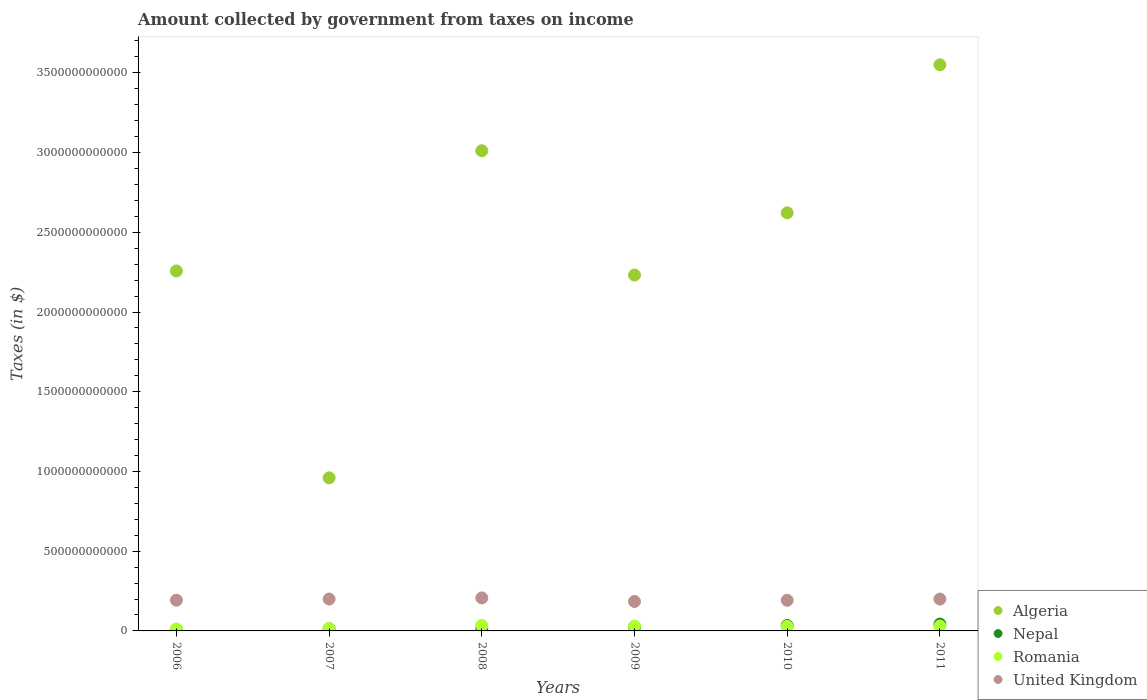How many different coloured dotlines are there?
Your response must be concise. 4. What is the amount collected by government from taxes on income in United Kingdom in 2009?
Offer a terse response. 1.85e+11. Across all years, what is the maximum amount collected by government from taxes on income in Romania?
Give a very brief answer. 3.40e+1. Across all years, what is the minimum amount collected by government from taxes on income in Romania?
Your answer should be very brief. 1.19e+1. What is the total amount collected by government from taxes on income in Algeria in the graph?
Offer a terse response. 1.46e+13. What is the difference between the amount collected by government from taxes on income in Nepal in 2008 and that in 2009?
Your answer should be compact. -7.42e+09. What is the difference between the amount collected by government from taxes on income in Algeria in 2007 and the amount collected by government from taxes on income in Romania in 2010?
Your response must be concise. 9.32e+11. What is the average amount collected by government from taxes on income in Nepal per year?
Keep it short and to the point. 2.34e+1. In the year 2008, what is the difference between the amount collected by government from taxes on income in United Kingdom and amount collected by government from taxes on income in Romania?
Your answer should be compact. 1.73e+11. What is the ratio of the amount collected by government from taxes on income in Nepal in 2006 to that in 2007?
Your answer should be very brief. 0.67. Is the amount collected by government from taxes on income in Romania in 2006 less than that in 2009?
Provide a succinct answer. Yes. Is the difference between the amount collected by government from taxes on income in United Kingdom in 2009 and 2010 greater than the difference between the amount collected by government from taxes on income in Romania in 2009 and 2010?
Your response must be concise. No. What is the difference between the highest and the second highest amount collected by government from taxes on income in United Kingdom?
Your answer should be compact. 6.88e+09. What is the difference between the highest and the lowest amount collected by government from taxes on income in Romania?
Ensure brevity in your answer.  2.21e+1. Is the sum of the amount collected by government from taxes on income in Algeria in 2007 and 2009 greater than the maximum amount collected by government from taxes on income in Nepal across all years?
Your answer should be very brief. Yes. Is the amount collected by government from taxes on income in Algeria strictly greater than the amount collected by government from taxes on income in Nepal over the years?
Ensure brevity in your answer.  Yes. How many dotlines are there?
Offer a very short reply. 4. What is the difference between two consecutive major ticks on the Y-axis?
Your answer should be compact. 5.00e+11. Where does the legend appear in the graph?
Offer a very short reply. Bottom right. What is the title of the graph?
Make the answer very short. Amount collected by government from taxes on income. Does "Namibia" appear as one of the legend labels in the graph?
Your answer should be very brief. No. What is the label or title of the X-axis?
Provide a succinct answer. Years. What is the label or title of the Y-axis?
Your answer should be compact. Taxes (in $). What is the Taxes (in $) of Algeria in 2006?
Ensure brevity in your answer.  2.26e+12. What is the Taxes (in $) of Nepal in 2006?
Your answer should be very brief. 9.16e+09. What is the Taxes (in $) of Romania in 2006?
Make the answer very short. 1.19e+1. What is the Taxes (in $) of United Kingdom in 2006?
Your answer should be very brief. 1.93e+11. What is the Taxes (in $) in Algeria in 2007?
Offer a terse response. 9.60e+11. What is the Taxes (in $) in Nepal in 2007?
Your answer should be very brief. 1.37e+1. What is the Taxes (in $) of Romania in 2007?
Your answer should be compact. 1.50e+1. What is the Taxes (in $) of United Kingdom in 2007?
Give a very brief answer. 2.00e+11. What is the Taxes (in $) in Algeria in 2008?
Your answer should be compact. 3.01e+12. What is the Taxes (in $) of Nepal in 2008?
Make the answer very short. 1.66e+1. What is the Taxes (in $) in Romania in 2008?
Provide a short and direct response. 3.40e+1. What is the Taxes (in $) in United Kingdom in 2008?
Make the answer very short. 2.07e+11. What is the Taxes (in $) of Algeria in 2009?
Your response must be concise. 2.23e+12. What is the Taxes (in $) in Nepal in 2009?
Your response must be concise. 2.41e+1. What is the Taxes (in $) of Romania in 2009?
Offer a very short reply. 3.06e+1. What is the Taxes (in $) of United Kingdom in 2009?
Provide a succinct answer. 1.85e+11. What is the Taxes (in $) in Algeria in 2010?
Make the answer very short. 2.62e+12. What is the Taxes (in $) of Nepal in 2010?
Keep it short and to the point. 3.38e+1. What is the Taxes (in $) of Romania in 2010?
Your answer should be compact. 2.82e+1. What is the Taxes (in $) in United Kingdom in 2010?
Your answer should be compact. 1.92e+11. What is the Taxes (in $) in Algeria in 2011?
Your answer should be compact. 3.55e+12. What is the Taxes (in $) in Nepal in 2011?
Offer a terse response. 4.31e+1. What is the Taxes (in $) in Romania in 2011?
Provide a succinct answer. 3.03e+1. What is the Taxes (in $) in United Kingdom in 2011?
Give a very brief answer. 2.00e+11. Across all years, what is the maximum Taxes (in $) of Algeria?
Offer a very short reply. 3.55e+12. Across all years, what is the maximum Taxes (in $) of Nepal?
Your answer should be very brief. 4.31e+1. Across all years, what is the maximum Taxes (in $) in Romania?
Provide a short and direct response. 3.40e+1. Across all years, what is the maximum Taxes (in $) of United Kingdom?
Give a very brief answer. 2.07e+11. Across all years, what is the minimum Taxes (in $) in Algeria?
Make the answer very short. 9.60e+11. Across all years, what is the minimum Taxes (in $) in Nepal?
Your answer should be very brief. 9.16e+09. Across all years, what is the minimum Taxes (in $) in Romania?
Your answer should be compact. 1.19e+1. Across all years, what is the minimum Taxes (in $) in United Kingdom?
Offer a terse response. 1.85e+11. What is the total Taxes (in $) in Algeria in the graph?
Give a very brief answer. 1.46e+13. What is the total Taxes (in $) in Nepal in the graph?
Make the answer very short. 1.41e+11. What is the total Taxes (in $) in Romania in the graph?
Your answer should be very brief. 1.50e+11. What is the total Taxes (in $) in United Kingdom in the graph?
Keep it short and to the point. 1.18e+12. What is the difference between the Taxes (in $) of Algeria in 2006 and that in 2007?
Provide a short and direct response. 1.30e+12. What is the difference between the Taxes (in $) of Nepal in 2006 and that in 2007?
Provide a short and direct response. -4.56e+09. What is the difference between the Taxes (in $) in Romania in 2006 and that in 2007?
Keep it short and to the point. -3.11e+09. What is the difference between the Taxes (in $) in United Kingdom in 2006 and that in 2007?
Provide a short and direct response. -7.44e+09. What is the difference between the Taxes (in $) of Algeria in 2006 and that in 2008?
Offer a very short reply. -7.54e+11. What is the difference between the Taxes (in $) of Nepal in 2006 and that in 2008?
Ensure brevity in your answer.  -7.46e+09. What is the difference between the Taxes (in $) in Romania in 2006 and that in 2008?
Ensure brevity in your answer.  -2.21e+1. What is the difference between the Taxes (in $) in United Kingdom in 2006 and that in 2008?
Ensure brevity in your answer.  -1.43e+1. What is the difference between the Taxes (in $) in Algeria in 2006 and that in 2009?
Your response must be concise. 2.57e+1. What is the difference between the Taxes (in $) in Nepal in 2006 and that in 2009?
Keep it short and to the point. -1.49e+1. What is the difference between the Taxes (in $) in Romania in 2006 and that in 2009?
Your answer should be very brief. -1.87e+1. What is the difference between the Taxes (in $) of United Kingdom in 2006 and that in 2009?
Make the answer very short. 7.80e+09. What is the difference between the Taxes (in $) in Algeria in 2006 and that in 2010?
Give a very brief answer. -3.65e+11. What is the difference between the Taxes (in $) in Nepal in 2006 and that in 2010?
Offer a very short reply. -2.47e+1. What is the difference between the Taxes (in $) of Romania in 2006 and that in 2010?
Offer a very short reply. -1.63e+1. What is the difference between the Taxes (in $) in United Kingdom in 2006 and that in 2010?
Ensure brevity in your answer.  4.79e+08. What is the difference between the Taxes (in $) in Algeria in 2006 and that in 2011?
Provide a short and direct response. -1.29e+12. What is the difference between the Taxes (in $) of Nepal in 2006 and that in 2011?
Offer a terse response. -3.40e+1. What is the difference between the Taxes (in $) in Romania in 2006 and that in 2011?
Give a very brief answer. -1.84e+1. What is the difference between the Taxes (in $) of United Kingdom in 2006 and that in 2011?
Give a very brief answer. -7.14e+09. What is the difference between the Taxes (in $) of Algeria in 2007 and that in 2008?
Provide a short and direct response. -2.05e+12. What is the difference between the Taxes (in $) in Nepal in 2007 and that in 2008?
Keep it short and to the point. -2.90e+09. What is the difference between the Taxes (in $) of Romania in 2007 and that in 2008?
Offer a very short reply. -1.90e+1. What is the difference between the Taxes (in $) in United Kingdom in 2007 and that in 2008?
Offer a very short reply. -6.88e+09. What is the difference between the Taxes (in $) in Algeria in 2007 and that in 2009?
Offer a very short reply. -1.27e+12. What is the difference between the Taxes (in $) in Nepal in 2007 and that in 2009?
Provide a succinct answer. -1.03e+1. What is the difference between the Taxes (in $) of Romania in 2007 and that in 2009?
Make the answer very short. -1.56e+1. What is the difference between the Taxes (in $) in United Kingdom in 2007 and that in 2009?
Offer a terse response. 1.52e+1. What is the difference between the Taxes (in $) of Algeria in 2007 and that in 2010?
Your answer should be compact. -1.66e+12. What is the difference between the Taxes (in $) in Nepal in 2007 and that in 2010?
Provide a succinct answer. -2.01e+1. What is the difference between the Taxes (in $) in Romania in 2007 and that in 2010?
Give a very brief answer. -1.32e+1. What is the difference between the Taxes (in $) of United Kingdom in 2007 and that in 2010?
Your answer should be very brief. 7.92e+09. What is the difference between the Taxes (in $) of Algeria in 2007 and that in 2011?
Offer a very short reply. -2.59e+12. What is the difference between the Taxes (in $) of Nepal in 2007 and that in 2011?
Offer a terse response. -2.94e+1. What is the difference between the Taxes (in $) in Romania in 2007 and that in 2011?
Provide a succinct answer. -1.53e+1. What is the difference between the Taxes (in $) in United Kingdom in 2007 and that in 2011?
Give a very brief answer. 3.00e+08. What is the difference between the Taxes (in $) in Algeria in 2008 and that in 2009?
Make the answer very short. 7.80e+11. What is the difference between the Taxes (in $) in Nepal in 2008 and that in 2009?
Provide a short and direct response. -7.42e+09. What is the difference between the Taxes (in $) of Romania in 2008 and that in 2009?
Keep it short and to the point. 3.39e+09. What is the difference between the Taxes (in $) of United Kingdom in 2008 and that in 2009?
Give a very brief answer. 2.21e+1. What is the difference between the Taxes (in $) of Algeria in 2008 and that in 2010?
Your answer should be compact. 3.89e+11. What is the difference between the Taxes (in $) of Nepal in 2008 and that in 2010?
Offer a terse response. -1.72e+1. What is the difference between the Taxes (in $) of Romania in 2008 and that in 2010?
Provide a succinct answer. 5.76e+09. What is the difference between the Taxes (in $) in United Kingdom in 2008 and that in 2010?
Make the answer very short. 1.48e+1. What is the difference between the Taxes (in $) of Algeria in 2008 and that in 2011?
Ensure brevity in your answer.  -5.39e+11. What is the difference between the Taxes (in $) in Nepal in 2008 and that in 2011?
Your answer should be very brief. -2.65e+1. What is the difference between the Taxes (in $) of Romania in 2008 and that in 2011?
Provide a succinct answer. 3.68e+09. What is the difference between the Taxes (in $) of United Kingdom in 2008 and that in 2011?
Your answer should be very brief. 7.18e+09. What is the difference between the Taxes (in $) of Algeria in 2009 and that in 2010?
Keep it short and to the point. -3.90e+11. What is the difference between the Taxes (in $) of Nepal in 2009 and that in 2010?
Ensure brevity in your answer.  -9.77e+09. What is the difference between the Taxes (in $) in Romania in 2009 and that in 2010?
Your response must be concise. 2.37e+09. What is the difference between the Taxes (in $) of United Kingdom in 2009 and that in 2010?
Offer a terse response. -7.32e+09. What is the difference between the Taxes (in $) in Algeria in 2009 and that in 2011?
Offer a very short reply. -1.32e+12. What is the difference between the Taxes (in $) in Nepal in 2009 and that in 2011?
Ensure brevity in your answer.  -1.91e+1. What is the difference between the Taxes (in $) in Romania in 2009 and that in 2011?
Keep it short and to the point. 2.83e+08. What is the difference between the Taxes (in $) of United Kingdom in 2009 and that in 2011?
Keep it short and to the point. -1.49e+1. What is the difference between the Taxes (in $) in Algeria in 2010 and that in 2011?
Make the answer very short. -9.28e+11. What is the difference between the Taxes (in $) of Nepal in 2010 and that in 2011?
Keep it short and to the point. -9.30e+09. What is the difference between the Taxes (in $) in Romania in 2010 and that in 2011?
Provide a short and direct response. -2.09e+09. What is the difference between the Taxes (in $) of United Kingdom in 2010 and that in 2011?
Make the answer very short. -7.62e+09. What is the difference between the Taxes (in $) in Algeria in 2006 and the Taxes (in $) in Nepal in 2007?
Offer a very short reply. 2.24e+12. What is the difference between the Taxes (in $) in Algeria in 2006 and the Taxes (in $) in Romania in 2007?
Offer a very short reply. 2.24e+12. What is the difference between the Taxes (in $) of Algeria in 2006 and the Taxes (in $) of United Kingdom in 2007?
Offer a terse response. 2.06e+12. What is the difference between the Taxes (in $) of Nepal in 2006 and the Taxes (in $) of Romania in 2007?
Give a very brief answer. -5.86e+09. What is the difference between the Taxes (in $) of Nepal in 2006 and the Taxes (in $) of United Kingdom in 2007?
Offer a very short reply. -1.91e+11. What is the difference between the Taxes (in $) in Romania in 2006 and the Taxes (in $) in United Kingdom in 2007?
Your answer should be very brief. -1.88e+11. What is the difference between the Taxes (in $) of Algeria in 2006 and the Taxes (in $) of Nepal in 2008?
Make the answer very short. 2.24e+12. What is the difference between the Taxes (in $) in Algeria in 2006 and the Taxes (in $) in Romania in 2008?
Your answer should be very brief. 2.22e+12. What is the difference between the Taxes (in $) in Algeria in 2006 and the Taxes (in $) in United Kingdom in 2008?
Provide a short and direct response. 2.05e+12. What is the difference between the Taxes (in $) of Nepal in 2006 and the Taxes (in $) of Romania in 2008?
Offer a very short reply. -2.48e+1. What is the difference between the Taxes (in $) of Nepal in 2006 and the Taxes (in $) of United Kingdom in 2008?
Ensure brevity in your answer.  -1.98e+11. What is the difference between the Taxes (in $) in Romania in 2006 and the Taxes (in $) in United Kingdom in 2008?
Provide a succinct answer. -1.95e+11. What is the difference between the Taxes (in $) in Algeria in 2006 and the Taxes (in $) in Nepal in 2009?
Give a very brief answer. 2.23e+12. What is the difference between the Taxes (in $) of Algeria in 2006 and the Taxes (in $) of Romania in 2009?
Your answer should be compact. 2.23e+12. What is the difference between the Taxes (in $) of Algeria in 2006 and the Taxes (in $) of United Kingdom in 2009?
Your answer should be very brief. 2.07e+12. What is the difference between the Taxes (in $) in Nepal in 2006 and the Taxes (in $) in Romania in 2009?
Your answer should be very brief. -2.14e+1. What is the difference between the Taxes (in $) of Nepal in 2006 and the Taxes (in $) of United Kingdom in 2009?
Give a very brief answer. -1.76e+11. What is the difference between the Taxes (in $) in Romania in 2006 and the Taxes (in $) in United Kingdom in 2009?
Give a very brief answer. -1.73e+11. What is the difference between the Taxes (in $) in Algeria in 2006 and the Taxes (in $) in Nepal in 2010?
Your response must be concise. 2.22e+12. What is the difference between the Taxes (in $) in Algeria in 2006 and the Taxes (in $) in Romania in 2010?
Your answer should be very brief. 2.23e+12. What is the difference between the Taxes (in $) in Algeria in 2006 and the Taxes (in $) in United Kingdom in 2010?
Provide a short and direct response. 2.07e+12. What is the difference between the Taxes (in $) of Nepal in 2006 and the Taxes (in $) of Romania in 2010?
Your answer should be compact. -1.91e+1. What is the difference between the Taxes (in $) in Nepal in 2006 and the Taxes (in $) in United Kingdom in 2010?
Provide a short and direct response. -1.83e+11. What is the difference between the Taxes (in $) in Romania in 2006 and the Taxes (in $) in United Kingdom in 2010?
Your response must be concise. -1.80e+11. What is the difference between the Taxes (in $) of Algeria in 2006 and the Taxes (in $) of Nepal in 2011?
Give a very brief answer. 2.21e+12. What is the difference between the Taxes (in $) in Algeria in 2006 and the Taxes (in $) in Romania in 2011?
Keep it short and to the point. 2.23e+12. What is the difference between the Taxes (in $) in Algeria in 2006 and the Taxes (in $) in United Kingdom in 2011?
Your answer should be very brief. 2.06e+12. What is the difference between the Taxes (in $) in Nepal in 2006 and the Taxes (in $) in Romania in 2011?
Keep it short and to the point. -2.12e+1. What is the difference between the Taxes (in $) in Nepal in 2006 and the Taxes (in $) in United Kingdom in 2011?
Provide a short and direct response. -1.91e+11. What is the difference between the Taxes (in $) of Romania in 2006 and the Taxes (in $) of United Kingdom in 2011?
Give a very brief answer. -1.88e+11. What is the difference between the Taxes (in $) in Algeria in 2007 and the Taxes (in $) in Nepal in 2008?
Offer a very short reply. 9.43e+11. What is the difference between the Taxes (in $) in Algeria in 2007 and the Taxes (in $) in Romania in 2008?
Ensure brevity in your answer.  9.26e+11. What is the difference between the Taxes (in $) of Algeria in 2007 and the Taxes (in $) of United Kingdom in 2008?
Offer a terse response. 7.53e+11. What is the difference between the Taxes (in $) of Nepal in 2007 and the Taxes (in $) of Romania in 2008?
Make the answer very short. -2.03e+1. What is the difference between the Taxes (in $) in Nepal in 2007 and the Taxes (in $) in United Kingdom in 2008?
Give a very brief answer. -1.93e+11. What is the difference between the Taxes (in $) of Romania in 2007 and the Taxes (in $) of United Kingdom in 2008?
Make the answer very short. -1.92e+11. What is the difference between the Taxes (in $) of Algeria in 2007 and the Taxes (in $) of Nepal in 2009?
Ensure brevity in your answer.  9.36e+11. What is the difference between the Taxes (in $) in Algeria in 2007 and the Taxes (in $) in Romania in 2009?
Your answer should be very brief. 9.29e+11. What is the difference between the Taxes (in $) of Algeria in 2007 and the Taxes (in $) of United Kingdom in 2009?
Your response must be concise. 7.75e+11. What is the difference between the Taxes (in $) in Nepal in 2007 and the Taxes (in $) in Romania in 2009?
Offer a very short reply. -1.69e+1. What is the difference between the Taxes (in $) in Nepal in 2007 and the Taxes (in $) in United Kingdom in 2009?
Provide a short and direct response. -1.71e+11. What is the difference between the Taxes (in $) of Romania in 2007 and the Taxes (in $) of United Kingdom in 2009?
Make the answer very short. -1.70e+11. What is the difference between the Taxes (in $) of Algeria in 2007 and the Taxes (in $) of Nepal in 2010?
Keep it short and to the point. 9.26e+11. What is the difference between the Taxes (in $) of Algeria in 2007 and the Taxes (in $) of Romania in 2010?
Your answer should be very brief. 9.32e+11. What is the difference between the Taxes (in $) of Algeria in 2007 and the Taxes (in $) of United Kingdom in 2010?
Offer a very short reply. 7.68e+11. What is the difference between the Taxes (in $) in Nepal in 2007 and the Taxes (in $) in Romania in 2010?
Offer a very short reply. -1.45e+1. What is the difference between the Taxes (in $) in Nepal in 2007 and the Taxes (in $) in United Kingdom in 2010?
Offer a terse response. -1.78e+11. What is the difference between the Taxes (in $) of Romania in 2007 and the Taxes (in $) of United Kingdom in 2010?
Your answer should be very brief. -1.77e+11. What is the difference between the Taxes (in $) of Algeria in 2007 and the Taxes (in $) of Nepal in 2011?
Ensure brevity in your answer.  9.17e+11. What is the difference between the Taxes (in $) of Algeria in 2007 and the Taxes (in $) of Romania in 2011?
Provide a succinct answer. 9.30e+11. What is the difference between the Taxes (in $) of Algeria in 2007 and the Taxes (in $) of United Kingdom in 2011?
Your answer should be very brief. 7.60e+11. What is the difference between the Taxes (in $) in Nepal in 2007 and the Taxes (in $) in Romania in 2011?
Offer a terse response. -1.66e+1. What is the difference between the Taxes (in $) in Nepal in 2007 and the Taxes (in $) in United Kingdom in 2011?
Offer a very short reply. -1.86e+11. What is the difference between the Taxes (in $) in Romania in 2007 and the Taxes (in $) in United Kingdom in 2011?
Your response must be concise. -1.85e+11. What is the difference between the Taxes (in $) in Algeria in 2008 and the Taxes (in $) in Nepal in 2009?
Ensure brevity in your answer.  2.99e+12. What is the difference between the Taxes (in $) of Algeria in 2008 and the Taxes (in $) of Romania in 2009?
Provide a short and direct response. 2.98e+12. What is the difference between the Taxes (in $) of Algeria in 2008 and the Taxes (in $) of United Kingdom in 2009?
Provide a short and direct response. 2.83e+12. What is the difference between the Taxes (in $) of Nepal in 2008 and the Taxes (in $) of Romania in 2009?
Make the answer very short. -1.40e+1. What is the difference between the Taxes (in $) of Nepal in 2008 and the Taxes (in $) of United Kingdom in 2009?
Give a very brief answer. -1.68e+11. What is the difference between the Taxes (in $) in Romania in 2008 and the Taxes (in $) in United Kingdom in 2009?
Provide a short and direct response. -1.51e+11. What is the difference between the Taxes (in $) of Algeria in 2008 and the Taxes (in $) of Nepal in 2010?
Provide a short and direct response. 2.98e+12. What is the difference between the Taxes (in $) in Algeria in 2008 and the Taxes (in $) in Romania in 2010?
Make the answer very short. 2.98e+12. What is the difference between the Taxes (in $) of Algeria in 2008 and the Taxes (in $) of United Kingdom in 2010?
Give a very brief answer. 2.82e+12. What is the difference between the Taxes (in $) in Nepal in 2008 and the Taxes (in $) in Romania in 2010?
Your response must be concise. -1.16e+1. What is the difference between the Taxes (in $) in Nepal in 2008 and the Taxes (in $) in United Kingdom in 2010?
Offer a very short reply. -1.75e+11. What is the difference between the Taxes (in $) of Romania in 2008 and the Taxes (in $) of United Kingdom in 2010?
Provide a short and direct response. -1.58e+11. What is the difference between the Taxes (in $) of Algeria in 2008 and the Taxes (in $) of Nepal in 2011?
Give a very brief answer. 2.97e+12. What is the difference between the Taxes (in $) in Algeria in 2008 and the Taxes (in $) in Romania in 2011?
Provide a short and direct response. 2.98e+12. What is the difference between the Taxes (in $) in Algeria in 2008 and the Taxes (in $) in United Kingdom in 2011?
Offer a very short reply. 2.81e+12. What is the difference between the Taxes (in $) in Nepal in 2008 and the Taxes (in $) in Romania in 2011?
Your response must be concise. -1.37e+1. What is the difference between the Taxes (in $) of Nepal in 2008 and the Taxes (in $) of United Kingdom in 2011?
Provide a succinct answer. -1.83e+11. What is the difference between the Taxes (in $) of Romania in 2008 and the Taxes (in $) of United Kingdom in 2011?
Make the answer very short. -1.66e+11. What is the difference between the Taxes (in $) in Algeria in 2009 and the Taxes (in $) in Nepal in 2010?
Keep it short and to the point. 2.20e+12. What is the difference between the Taxes (in $) in Algeria in 2009 and the Taxes (in $) in Romania in 2010?
Offer a terse response. 2.20e+12. What is the difference between the Taxes (in $) of Algeria in 2009 and the Taxes (in $) of United Kingdom in 2010?
Make the answer very short. 2.04e+12. What is the difference between the Taxes (in $) in Nepal in 2009 and the Taxes (in $) in Romania in 2010?
Give a very brief answer. -4.19e+09. What is the difference between the Taxes (in $) in Nepal in 2009 and the Taxes (in $) in United Kingdom in 2010?
Your answer should be compact. -1.68e+11. What is the difference between the Taxes (in $) of Romania in 2009 and the Taxes (in $) of United Kingdom in 2010?
Give a very brief answer. -1.62e+11. What is the difference between the Taxes (in $) of Algeria in 2009 and the Taxes (in $) of Nepal in 2011?
Your answer should be very brief. 2.19e+12. What is the difference between the Taxes (in $) of Algeria in 2009 and the Taxes (in $) of Romania in 2011?
Provide a short and direct response. 2.20e+12. What is the difference between the Taxes (in $) of Algeria in 2009 and the Taxes (in $) of United Kingdom in 2011?
Offer a terse response. 2.03e+12. What is the difference between the Taxes (in $) of Nepal in 2009 and the Taxes (in $) of Romania in 2011?
Offer a terse response. -6.28e+09. What is the difference between the Taxes (in $) in Nepal in 2009 and the Taxes (in $) in United Kingdom in 2011?
Make the answer very short. -1.76e+11. What is the difference between the Taxes (in $) of Romania in 2009 and the Taxes (in $) of United Kingdom in 2011?
Your answer should be very brief. -1.69e+11. What is the difference between the Taxes (in $) of Algeria in 2010 and the Taxes (in $) of Nepal in 2011?
Provide a short and direct response. 2.58e+12. What is the difference between the Taxes (in $) of Algeria in 2010 and the Taxes (in $) of Romania in 2011?
Provide a short and direct response. 2.59e+12. What is the difference between the Taxes (in $) in Algeria in 2010 and the Taxes (in $) in United Kingdom in 2011?
Give a very brief answer. 2.42e+12. What is the difference between the Taxes (in $) of Nepal in 2010 and the Taxes (in $) of Romania in 2011?
Your answer should be compact. 3.49e+09. What is the difference between the Taxes (in $) in Nepal in 2010 and the Taxes (in $) in United Kingdom in 2011?
Your answer should be compact. -1.66e+11. What is the difference between the Taxes (in $) of Romania in 2010 and the Taxes (in $) of United Kingdom in 2011?
Offer a very short reply. -1.71e+11. What is the average Taxes (in $) in Algeria per year?
Your response must be concise. 2.44e+12. What is the average Taxes (in $) in Nepal per year?
Provide a succinct answer. 2.34e+1. What is the average Taxes (in $) in Romania per year?
Your response must be concise. 2.50e+1. What is the average Taxes (in $) in United Kingdom per year?
Your response must be concise. 1.96e+11. In the year 2006, what is the difference between the Taxes (in $) in Algeria and Taxes (in $) in Nepal?
Provide a short and direct response. 2.25e+12. In the year 2006, what is the difference between the Taxes (in $) of Algeria and Taxes (in $) of Romania?
Offer a very short reply. 2.25e+12. In the year 2006, what is the difference between the Taxes (in $) in Algeria and Taxes (in $) in United Kingdom?
Offer a very short reply. 2.06e+12. In the year 2006, what is the difference between the Taxes (in $) in Nepal and Taxes (in $) in Romania?
Ensure brevity in your answer.  -2.75e+09. In the year 2006, what is the difference between the Taxes (in $) in Nepal and Taxes (in $) in United Kingdom?
Offer a terse response. -1.83e+11. In the year 2006, what is the difference between the Taxes (in $) of Romania and Taxes (in $) of United Kingdom?
Make the answer very short. -1.81e+11. In the year 2007, what is the difference between the Taxes (in $) of Algeria and Taxes (in $) of Nepal?
Keep it short and to the point. 9.46e+11. In the year 2007, what is the difference between the Taxes (in $) of Algeria and Taxes (in $) of Romania?
Give a very brief answer. 9.45e+11. In the year 2007, what is the difference between the Taxes (in $) in Algeria and Taxes (in $) in United Kingdom?
Make the answer very short. 7.60e+11. In the year 2007, what is the difference between the Taxes (in $) in Nepal and Taxes (in $) in Romania?
Provide a short and direct response. -1.30e+09. In the year 2007, what is the difference between the Taxes (in $) of Nepal and Taxes (in $) of United Kingdom?
Provide a succinct answer. -1.86e+11. In the year 2007, what is the difference between the Taxes (in $) in Romania and Taxes (in $) in United Kingdom?
Give a very brief answer. -1.85e+11. In the year 2008, what is the difference between the Taxes (in $) of Algeria and Taxes (in $) of Nepal?
Give a very brief answer. 2.99e+12. In the year 2008, what is the difference between the Taxes (in $) of Algeria and Taxes (in $) of Romania?
Give a very brief answer. 2.98e+12. In the year 2008, what is the difference between the Taxes (in $) of Algeria and Taxes (in $) of United Kingdom?
Provide a short and direct response. 2.80e+12. In the year 2008, what is the difference between the Taxes (in $) of Nepal and Taxes (in $) of Romania?
Your response must be concise. -1.74e+1. In the year 2008, what is the difference between the Taxes (in $) in Nepal and Taxes (in $) in United Kingdom?
Provide a succinct answer. -1.90e+11. In the year 2008, what is the difference between the Taxes (in $) of Romania and Taxes (in $) of United Kingdom?
Provide a short and direct response. -1.73e+11. In the year 2009, what is the difference between the Taxes (in $) of Algeria and Taxes (in $) of Nepal?
Make the answer very short. 2.21e+12. In the year 2009, what is the difference between the Taxes (in $) in Algeria and Taxes (in $) in Romania?
Make the answer very short. 2.20e+12. In the year 2009, what is the difference between the Taxes (in $) in Algeria and Taxes (in $) in United Kingdom?
Offer a terse response. 2.05e+12. In the year 2009, what is the difference between the Taxes (in $) of Nepal and Taxes (in $) of Romania?
Offer a very short reply. -6.56e+09. In the year 2009, what is the difference between the Taxes (in $) in Nepal and Taxes (in $) in United Kingdom?
Give a very brief answer. -1.61e+11. In the year 2009, what is the difference between the Taxes (in $) of Romania and Taxes (in $) of United Kingdom?
Provide a short and direct response. -1.54e+11. In the year 2010, what is the difference between the Taxes (in $) in Algeria and Taxes (in $) in Nepal?
Your response must be concise. 2.59e+12. In the year 2010, what is the difference between the Taxes (in $) of Algeria and Taxes (in $) of Romania?
Provide a short and direct response. 2.59e+12. In the year 2010, what is the difference between the Taxes (in $) of Algeria and Taxes (in $) of United Kingdom?
Your answer should be compact. 2.43e+12. In the year 2010, what is the difference between the Taxes (in $) of Nepal and Taxes (in $) of Romania?
Offer a terse response. 5.58e+09. In the year 2010, what is the difference between the Taxes (in $) of Nepal and Taxes (in $) of United Kingdom?
Ensure brevity in your answer.  -1.58e+11. In the year 2010, what is the difference between the Taxes (in $) in Romania and Taxes (in $) in United Kingdom?
Offer a terse response. -1.64e+11. In the year 2011, what is the difference between the Taxes (in $) in Algeria and Taxes (in $) in Nepal?
Your answer should be compact. 3.51e+12. In the year 2011, what is the difference between the Taxes (in $) in Algeria and Taxes (in $) in Romania?
Keep it short and to the point. 3.52e+12. In the year 2011, what is the difference between the Taxes (in $) in Algeria and Taxes (in $) in United Kingdom?
Offer a very short reply. 3.35e+12. In the year 2011, what is the difference between the Taxes (in $) of Nepal and Taxes (in $) of Romania?
Make the answer very short. 1.28e+1. In the year 2011, what is the difference between the Taxes (in $) of Nepal and Taxes (in $) of United Kingdom?
Provide a short and direct response. -1.57e+11. In the year 2011, what is the difference between the Taxes (in $) in Romania and Taxes (in $) in United Kingdom?
Make the answer very short. -1.69e+11. What is the ratio of the Taxes (in $) in Algeria in 2006 to that in 2007?
Offer a very short reply. 2.35. What is the ratio of the Taxes (in $) in Nepal in 2006 to that in 2007?
Make the answer very short. 0.67. What is the ratio of the Taxes (in $) of Romania in 2006 to that in 2007?
Your response must be concise. 0.79. What is the ratio of the Taxes (in $) in United Kingdom in 2006 to that in 2007?
Make the answer very short. 0.96. What is the ratio of the Taxes (in $) in Algeria in 2006 to that in 2008?
Provide a succinct answer. 0.75. What is the ratio of the Taxes (in $) in Nepal in 2006 to that in 2008?
Your answer should be compact. 0.55. What is the ratio of the Taxes (in $) of Romania in 2006 to that in 2008?
Your answer should be very brief. 0.35. What is the ratio of the Taxes (in $) of United Kingdom in 2006 to that in 2008?
Give a very brief answer. 0.93. What is the ratio of the Taxes (in $) in Algeria in 2006 to that in 2009?
Offer a very short reply. 1.01. What is the ratio of the Taxes (in $) in Nepal in 2006 to that in 2009?
Provide a short and direct response. 0.38. What is the ratio of the Taxes (in $) in Romania in 2006 to that in 2009?
Keep it short and to the point. 0.39. What is the ratio of the Taxes (in $) in United Kingdom in 2006 to that in 2009?
Make the answer very short. 1.04. What is the ratio of the Taxes (in $) of Algeria in 2006 to that in 2010?
Your answer should be very brief. 0.86. What is the ratio of the Taxes (in $) in Nepal in 2006 to that in 2010?
Offer a terse response. 0.27. What is the ratio of the Taxes (in $) of Romania in 2006 to that in 2010?
Your answer should be compact. 0.42. What is the ratio of the Taxes (in $) in Algeria in 2006 to that in 2011?
Offer a terse response. 0.64. What is the ratio of the Taxes (in $) of Nepal in 2006 to that in 2011?
Offer a terse response. 0.21. What is the ratio of the Taxes (in $) in Romania in 2006 to that in 2011?
Ensure brevity in your answer.  0.39. What is the ratio of the Taxes (in $) of United Kingdom in 2006 to that in 2011?
Offer a very short reply. 0.96. What is the ratio of the Taxes (in $) of Algeria in 2007 to that in 2008?
Provide a succinct answer. 0.32. What is the ratio of the Taxes (in $) in Nepal in 2007 to that in 2008?
Give a very brief answer. 0.83. What is the ratio of the Taxes (in $) in Romania in 2007 to that in 2008?
Ensure brevity in your answer.  0.44. What is the ratio of the Taxes (in $) of United Kingdom in 2007 to that in 2008?
Provide a short and direct response. 0.97. What is the ratio of the Taxes (in $) of Algeria in 2007 to that in 2009?
Provide a succinct answer. 0.43. What is the ratio of the Taxes (in $) in Nepal in 2007 to that in 2009?
Your answer should be very brief. 0.57. What is the ratio of the Taxes (in $) in Romania in 2007 to that in 2009?
Offer a very short reply. 0.49. What is the ratio of the Taxes (in $) in United Kingdom in 2007 to that in 2009?
Your response must be concise. 1.08. What is the ratio of the Taxes (in $) of Algeria in 2007 to that in 2010?
Ensure brevity in your answer.  0.37. What is the ratio of the Taxes (in $) of Nepal in 2007 to that in 2010?
Give a very brief answer. 0.41. What is the ratio of the Taxes (in $) in Romania in 2007 to that in 2010?
Your response must be concise. 0.53. What is the ratio of the Taxes (in $) in United Kingdom in 2007 to that in 2010?
Offer a terse response. 1.04. What is the ratio of the Taxes (in $) in Algeria in 2007 to that in 2011?
Make the answer very short. 0.27. What is the ratio of the Taxes (in $) of Nepal in 2007 to that in 2011?
Offer a terse response. 0.32. What is the ratio of the Taxes (in $) in Romania in 2007 to that in 2011?
Your answer should be very brief. 0.5. What is the ratio of the Taxes (in $) of United Kingdom in 2007 to that in 2011?
Provide a succinct answer. 1. What is the ratio of the Taxes (in $) of Algeria in 2008 to that in 2009?
Make the answer very short. 1.35. What is the ratio of the Taxes (in $) of Nepal in 2008 to that in 2009?
Your response must be concise. 0.69. What is the ratio of the Taxes (in $) in Romania in 2008 to that in 2009?
Ensure brevity in your answer.  1.11. What is the ratio of the Taxes (in $) in United Kingdom in 2008 to that in 2009?
Offer a very short reply. 1.12. What is the ratio of the Taxes (in $) in Algeria in 2008 to that in 2010?
Ensure brevity in your answer.  1.15. What is the ratio of the Taxes (in $) in Nepal in 2008 to that in 2010?
Ensure brevity in your answer.  0.49. What is the ratio of the Taxes (in $) of Romania in 2008 to that in 2010?
Ensure brevity in your answer.  1.2. What is the ratio of the Taxes (in $) in United Kingdom in 2008 to that in 2010?
Offer a terse response. 1.08. What is the ratio of the Taxes (in $) of Algeria in 2008 to that in 2011?
Your answer should be very brief. 0.85. What is the ratio of the Taxes (in $) of Nepal in 2008 to that in 2011?
Your answer should be compact. 0.39. What is the ratio of the Taxes (in $) of Romania in 2008 to that in 2011?
Give a very brief answer. 1.12. What is the ratio of the Taxes (in $) of United Kingdom in 2008 to that in 2011?
Keep it short and to the point. 1.04. What is the ratio of the Taxes (in $) in Algeria in 2009 to that in 2010?
Make the answer very short. 0.85. What is the ratio of the Taxes (in $) of Nepal in 2009 to that in 2010?
Give a very brief answer. 0.71. What is the ratio of the Taxes (in $) in Romania in 2009 to that in 2010?
Provide a succinct answer. 1.08. What is the ratio of the Taxes (in $) of United Kingdom in 2009 to that in 2010?
Your answer should be very brief. 0.96. What is the ratio of the Taxes (in $) of Algeria in 2009 to that in 2011?
Your answer should be compact. 0.63. What is the ratio of the Taxes (in $) of Nepal in 2009 to that in 2011?
Ensure brevity in your answer.  0.56. What is the ratio of the Taxes (in $) of Romania in 2009 to that in 2011?
Offer a very short reply. 1.01. What is the ratio of the Taxes (in $) in United Kingdom in 2009 to that in 2011?
Your response must be concise. 0.93. What is the ratio of the Taxes (in $) of Algeria in 2010 to that in 2011?
Give a very brief answer. 0.74. What is the ratio of the Taxes (in $) in Nepal in 2010 to that in 2011?
Offer a very short reply. 0.78. What is the ratio of the Taxes (in $) in Romania in 2010 to that in 2011?
Offer a terse response. 0.93. What is the ratio of the Taxes (in $) in United Kingdom in 2010 to that in 2011?
Keep it short and to the point. 0.96. What is the difference between the highest and the second highest Taxes (in $) of Algeria?
Your response must be concise. 5.39e+11. What is the difference between the highest and the second highest Taxes (in $) of Nepal?
Provide a short and direct response. 9.30e+09. What is the difference between the highest and the second highest Taxes (in $) of Romania?
Your response must be concise. 3.39e+09. What is the difference between the highest and the second highest Taxes (in $) in United Kingdom?
Make the answer very short. 6.88e+09. What is the difference between the highest and the lowest Taxes (in $) of Algeria?
Keep it short and to the point. 2.59e+12. What is the difference between the highest and the lowest Taxes (in $) in Nepal?
Offer a very short reply. 3.40e+1. What is the difference between the highest and the lowest Taxes (in $) in Romania?
Offer a very short reply. 2.21e+1. What is the difference between the highest and the lowest Taxes (in $) of United Kingdom?
Provide a short and direct response. 2.21e+1. 